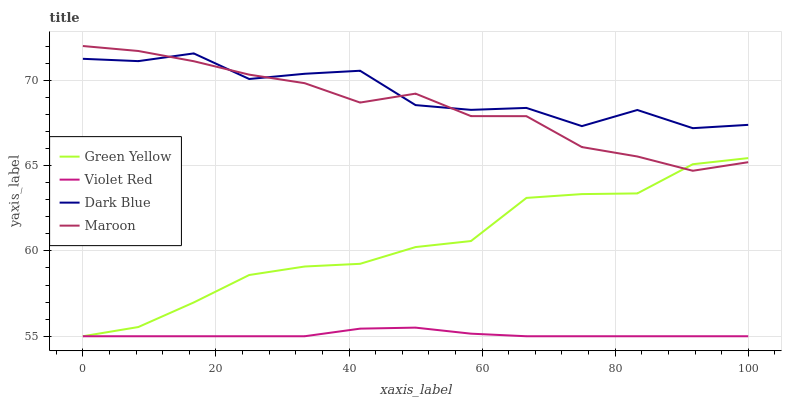Does Violet Red have the minimum area under the curve?
Answer yes or no. Yes. Does Dark Blue have the maximum area under the curve?
Answer yes or no. Yes. Does Green Yellow have the minimum area under the curve?
Answer yes or no. No. Does Green Yellow have the maximum area under the curve?
Answer yes or no. No. Is Violet Red the smoothest?
Answer yes or no. Yes. Is Dark Blue the roughest?
Answer yes or no. Yes. Is Green Yellow the smoothest?
Answer yes or no. No. Is Green Yellow the roughest?
Answer yes or no. No. Does Violet Red have the lowest value?
Answer yes or no. Yes. Does Maroon have the lowest value?
Answer yes or no. No. Does Maroon have the highest value?
Answer yes or no. Yes. Does Green Yellow have the highest value?
Answer yes or no. No. Is Violet Red less than Dark Blue?
Answer yes or no. Yes. Is Dark Blue greater than Green Yellow?
Answer yes or no. Yes. Does Green Yellow intersect Violet Red?
Answer yes or no. Yes. Is Green Yellow less than Violet Red?
Answer yes or no. No. Is Green Yellow greater than Violet Red?
Answer yes or no. No. Does Violet Red intersect Dark Blue?
Answer yes or no. No. 